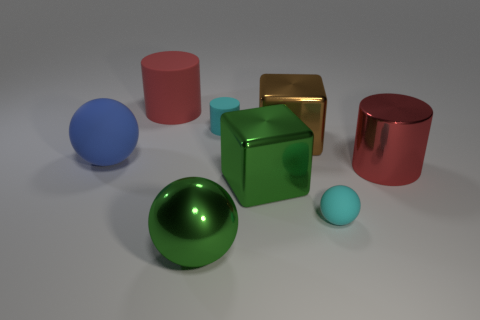The big sphere in front of the big shiny cylinder is what color? green 